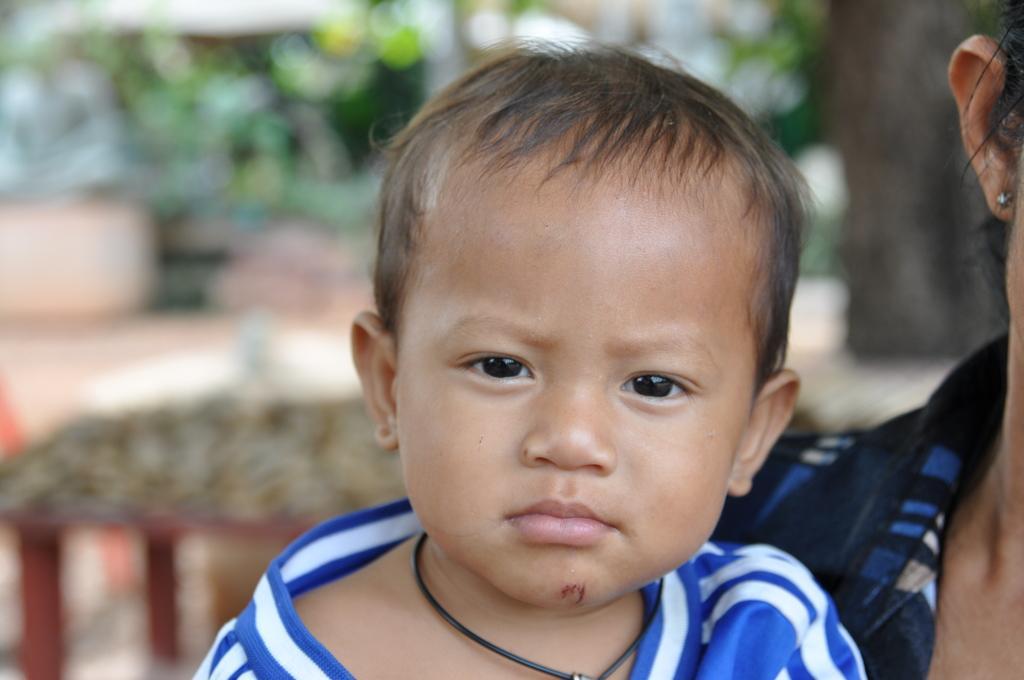In one or two sentences, can you explain what this image depicts? Here we can see a kid and a person. There is a blur background. 